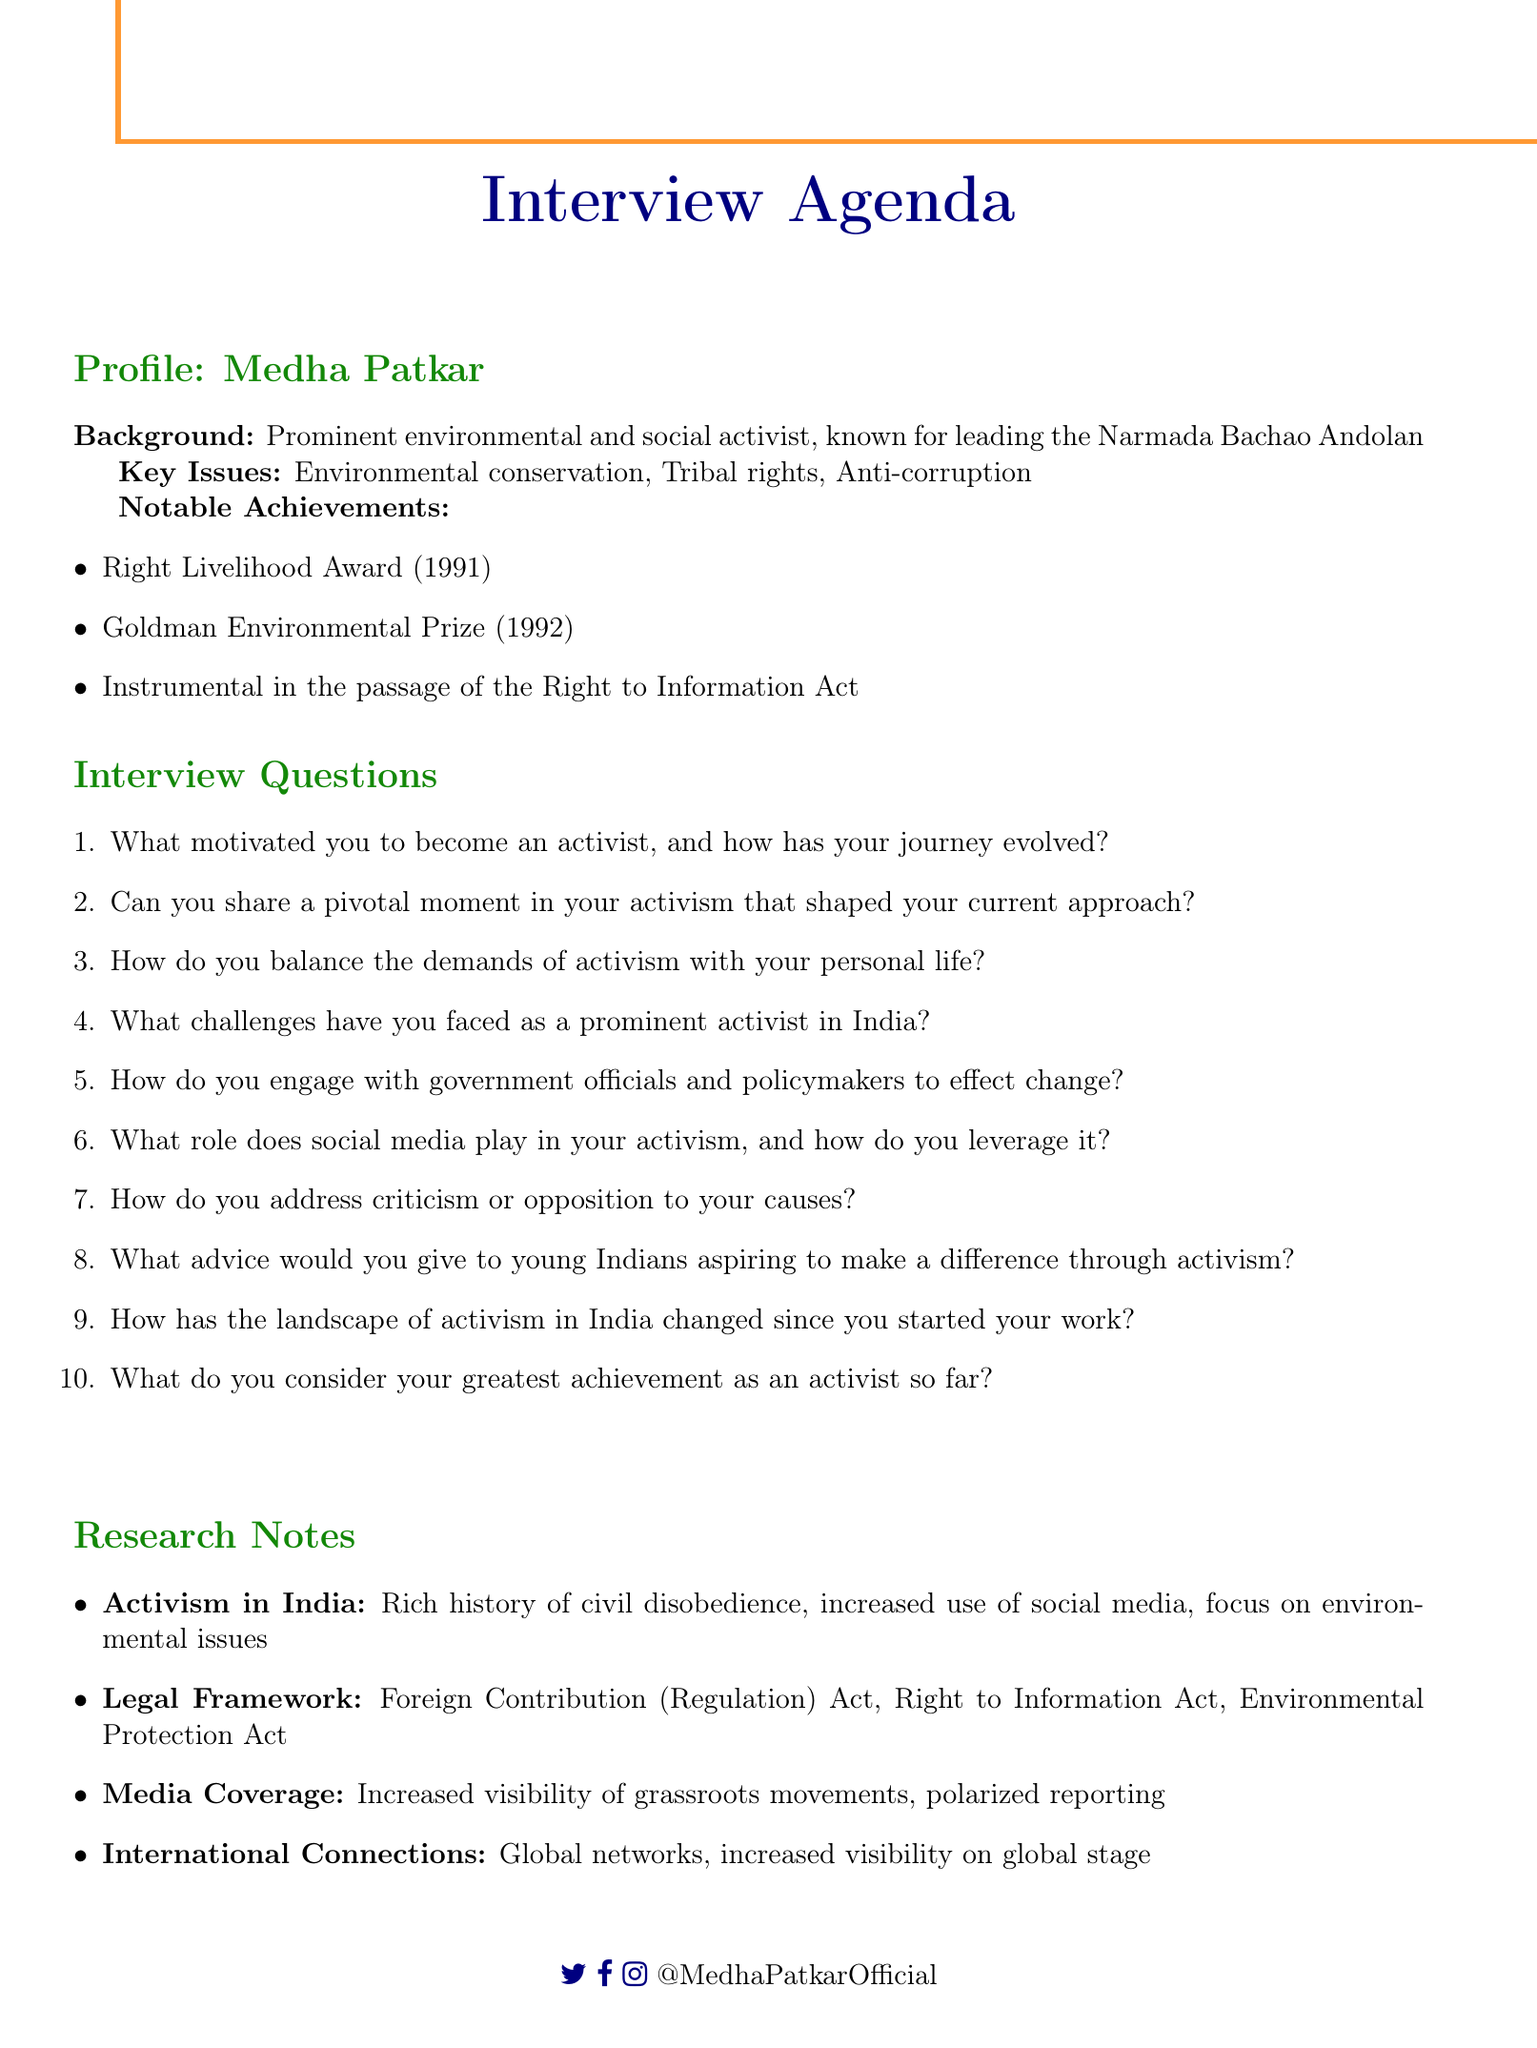What is the name of the activist featured in the document? The document introduces Medha Patkar as the prominent activist whose profile is discussed.
Answer: Medha Patkar What key issue is Medha Patkar known for? The document lists environmental conservation, tribal rights, and anti-corruption as key issues related to Medha Patkar's activism.
Answer: Environmental conservation Which award did Medha Patkar receive in 1991? The document mentions that she received the Right Livelihood Award in 1991 as one of her notable achievements.
Answer: Right Livelihood Award What is a notable achievement of Medha Patkar besides awards? The document highlights her instrumental role in the passage of the Right to Information Act as a significant achievement.
Answer: Instrumental in the passage of the Right to Information Act What current trend is mentioned regarding activism in India? The document notes the increased use of social media for mobilization as a current trend in activism.
Answer: Increased use of social media for mobilization What is one challenge faced by activists in India according to the document? The document lists government restrictions on NGOs as a challenge faced by activists in India.
Answer: Government restrictions on NGOs What type of media is gaining importance in coverage of activist causes? The document states that independent media platforms are becoming increasingly important in coverage of activist causes.
Answer: Independent media platforms What legal act is associated with international funding for NGOs? The document refers to the Foreign Contribution (Regulation) Act as relevant to the legal framework regarding international funding.
Answer: Foreign Contribution (Regulation) Act What global entity is mentioned in relation to international connections of activism? The document lists United Nations bodies as part of the global networks surrounding activism.
Answer: United Nations bodies 